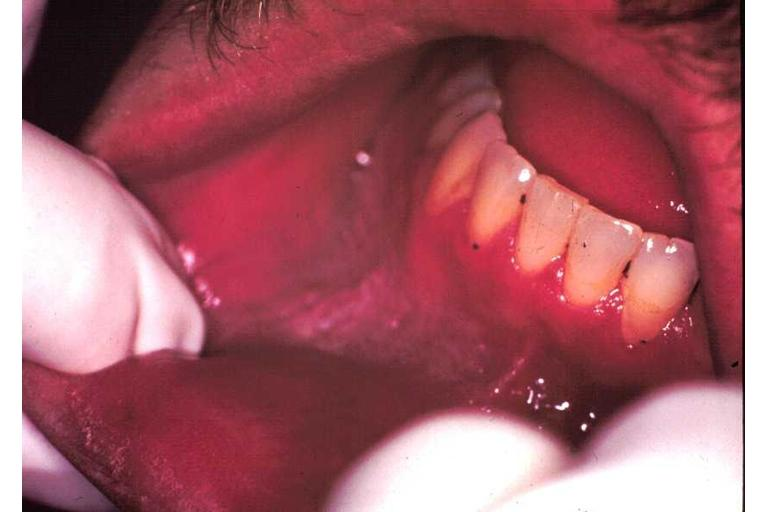what is present?
Answer the question using a single word or phrase. Oral 